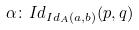<formula> <loc_0><loc_0><loc_500><loc_500>\alpha \colon I d _ { I d _ { A } ( a , b ) } ( p , q )</formula> 